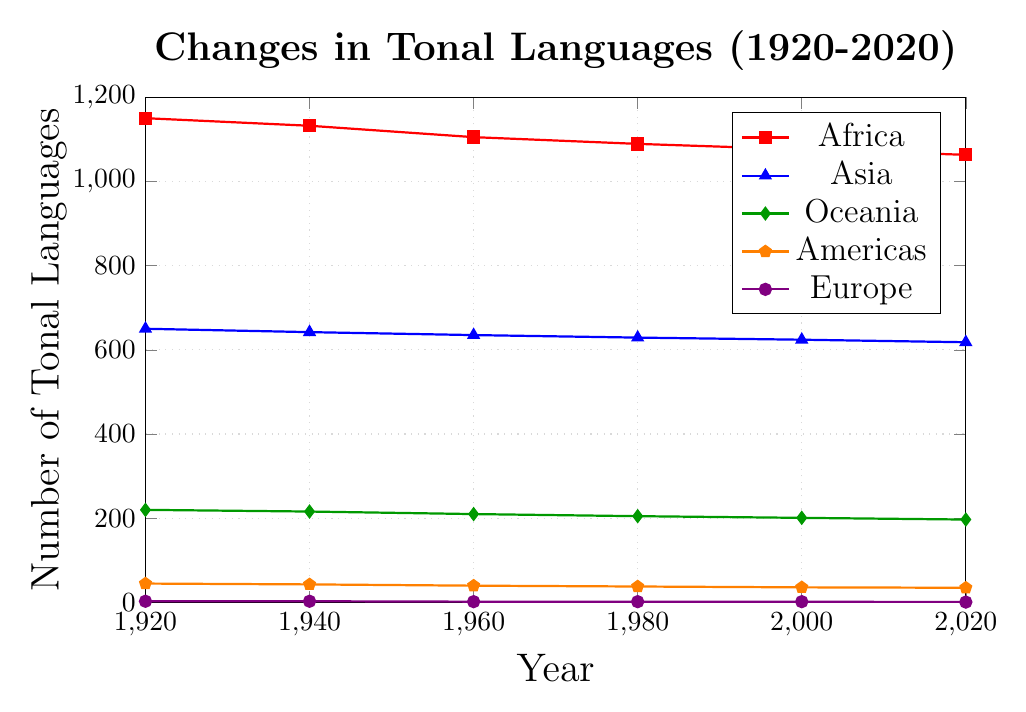What continent had the highest number of tonal languages in 1920? In the figure, the series representing Africa is the highest in 1920 at approximately 1150.
Answer: Africa How did the number of tonal languages in the Americas change from 1920 to 2020? The data for the Americas shows a decrease in tonal languages over the years: from 45 in 1920 down to 35 in 2020. The change is calculated as 45 - 35 = 10.
Answer: Decreased by 10 Which continent experienced the steepest decline in tonal languages between 1960 and 2020? By calculating the difference between 1960 and 2020 for each continent, we get Africa: 1105 - 1063 = 42, Asia: 635 - 618 = 17, Oceania: 210 - 197 = 13, Americas: 40 - 35 = 5, and Europe: 2 - 1 = 1. Therefore, Africa had the largest decline of 42.
Answer: Africa By what proportion did the number of tonal languages in Oceania decrease from 1920 to 2020? The number of tonal languages in Oceania decreased from 220 in 1920 to 197 in 2020. The change is 220 - 197 = 23. The proportion is 23 / 220 ≈ 0.1045.
Answer: Approximately 0.1045 What is the approximate average number of tonal languages in Asia from 1920 to 2020, based on the data points provided? Summing the values for Asia (650, 642, 635, 629, 624, 618) gives 3798. The average is 3798 / 6 ≈ 633.
Answer: Approximately 633 Which two continents have the closest number of tonal languages in 1980? In 1980, the values are Africa: 1089, Asia: 629, Oceania: 205, Americas: 38, and Europe: 2. The closest values are Oceania and Americas, which differ by only 167.
Answer: Oceania and Americas What's the ratio of the number of tonal languages in Africa to Europe in 2000? In 2000, Africa had 1076 tonal languages, while Europe had 2. The ratio is 1076 / 2 = 538.
Answer: 538 What is the total number of tonal languages across all continents in 1920? Summing the values in 1920 (Africa: 1150, Asia: 650, Oceania: 220, Americas: 45, Europe: 3) gives 1150 + 650 + 220 + 45 + 3 = 2068.
Answer: 2068 In which decade did Asia experience the smallest decline in the number of tonal languages? Calculating changes decade-wise for Asia: between 1920-1940: 650 - 642 = 8, 1940-1960: 642 - 635 = 7, 1960-1980: 635 - 629 = 6, 1980-2000: 629 - 624 = 5, 2000-2020: 624 - 618 = 6. The smallest decline is in the 1980-2000 period.
Answer: 1980-2000 